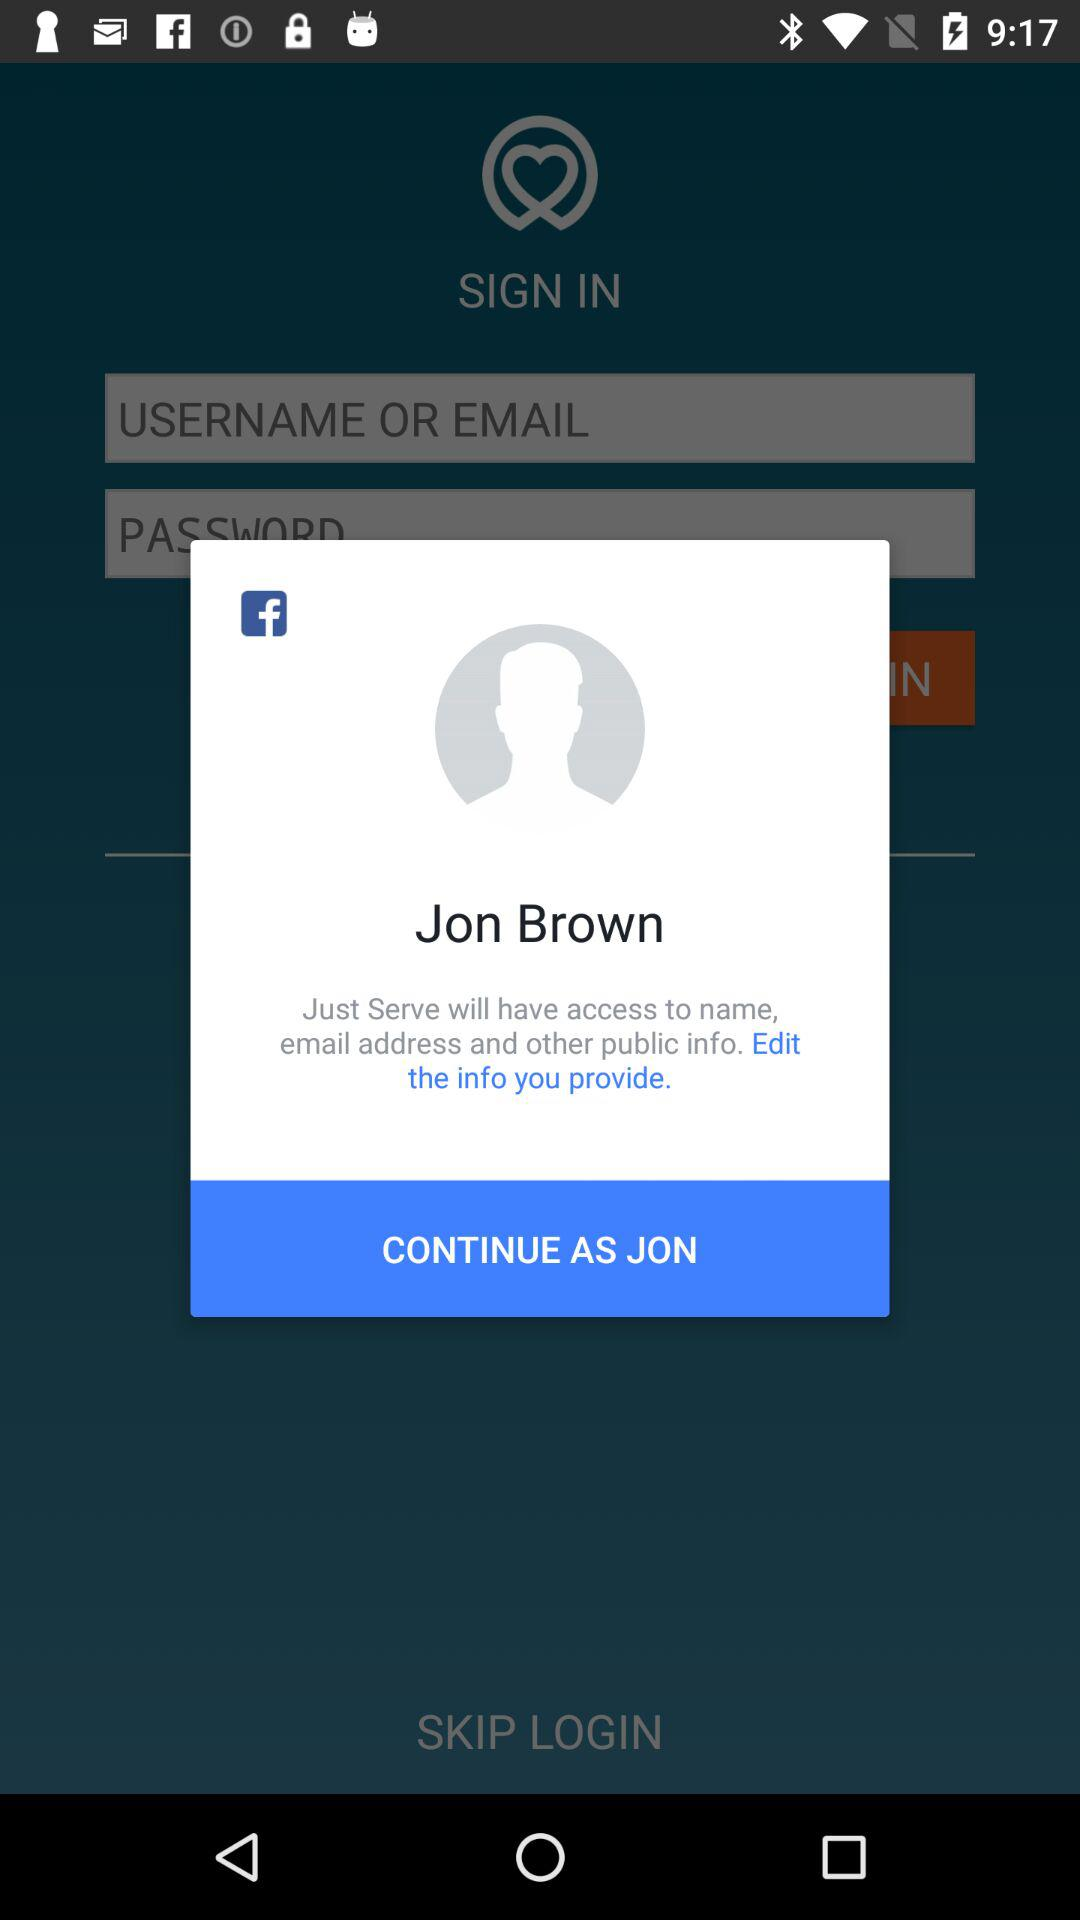Through what application can a user continue? The application through which a user can continue is "Facebook". 